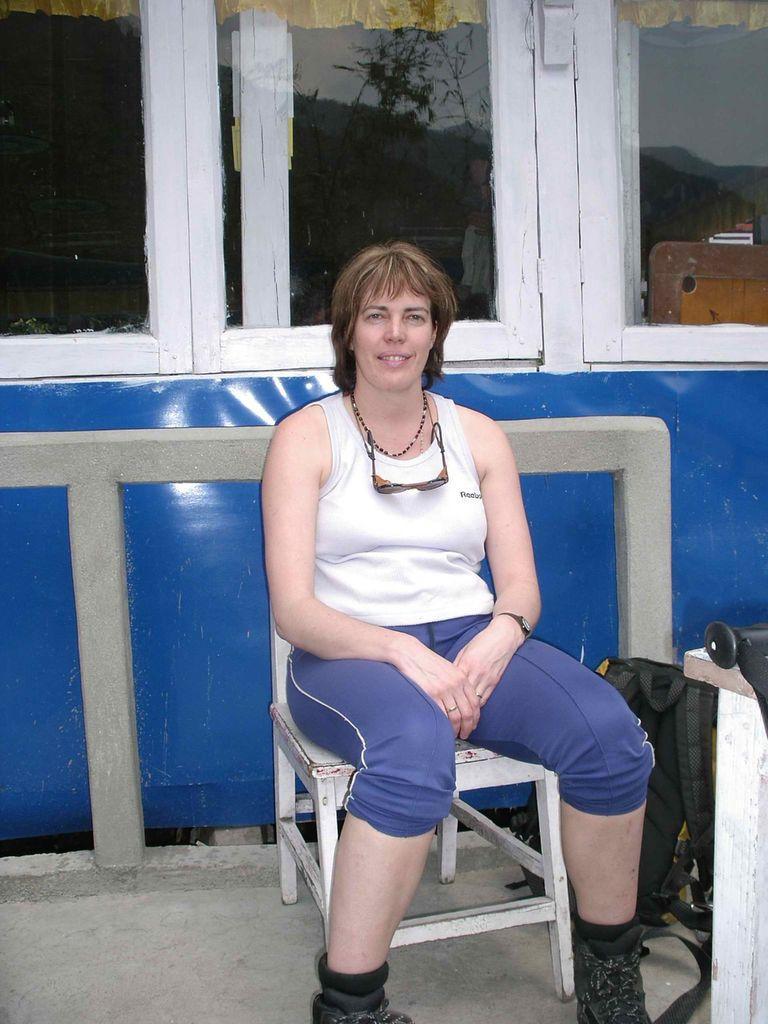How would you summarize this image in a sentence or two? In this image we can see a woman sitting on the chair which is on the ground and she is smiling. In the background there is a fence and also the glass windows and with the help of the glass window we can see the trees, sky and also the hills. On the right there is a black color bag. 